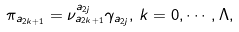<formula> <loc_0><loc_0><loc_500><loc_500>\pi _ { a _ { 2 k + 1 } } = \nu _ { a _ { 2 k + 1 } } ^ { a _ { 2 j } } \gamma _ { a _ { 2 j } } , \, k = 0 , \cdots , \Lambda ,</formula> 